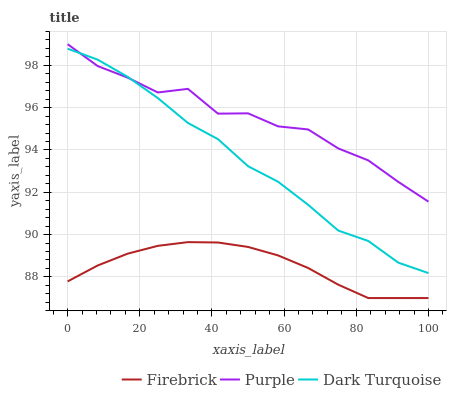Does Firebrick have the minimum area under the curve?
Answer yes or no. Yes. Does Purple have the maximum area under the curve?
Answer yes or no. Yes. Does Dark Turquoise have the minimum area under the curve?
Answer yes or no. No. Does Dark Turquoise have the maximum area under the curve?
Answer yes or no. No. Is Firebrick the smoothest?
Answer yes or no. Yes. Is Purple the roughest?
Answer yes or no. Yes. Is Dark Turquoise the smoothest?
Answer yes or no. No. Is Dark Turquoise the roughest?
Answer yes or no. No. Does Firebrick have the lowest value?
Answer yes or no. Yes. Does Dark Turquoise have the lowest value?
Answer yes or no. No. Does Purple have the highest value?
Answer yes or no. Yes. Does Dark Turquoise have the highest value?
Answer yes or no. No. Is Firebrick less than Purple?
Answer yes or no. Yes. Is Dark Turquoise greater than Firebrick?
Answer yes or no. Yes. Does Purple intersect Dark Turquoise?
Answer yes or no. Yes. Is Purple less than Dark Turquoise?
Answer yes or no. No. Is Purple greater than Dark Turquoise?
Answer yes or no. No. Does Firebrick intersect Purple?
Answer yes or no. No. 